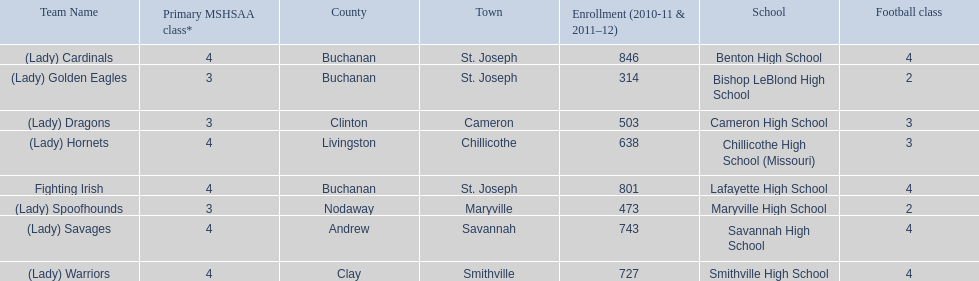What school in midland empire conference has 846 students enrolled? Benton High School. What school has 314 students enrolled? Bishop LeBlond High School. What school had 638 students enrolled? Chillicothe High School (Missouri). 